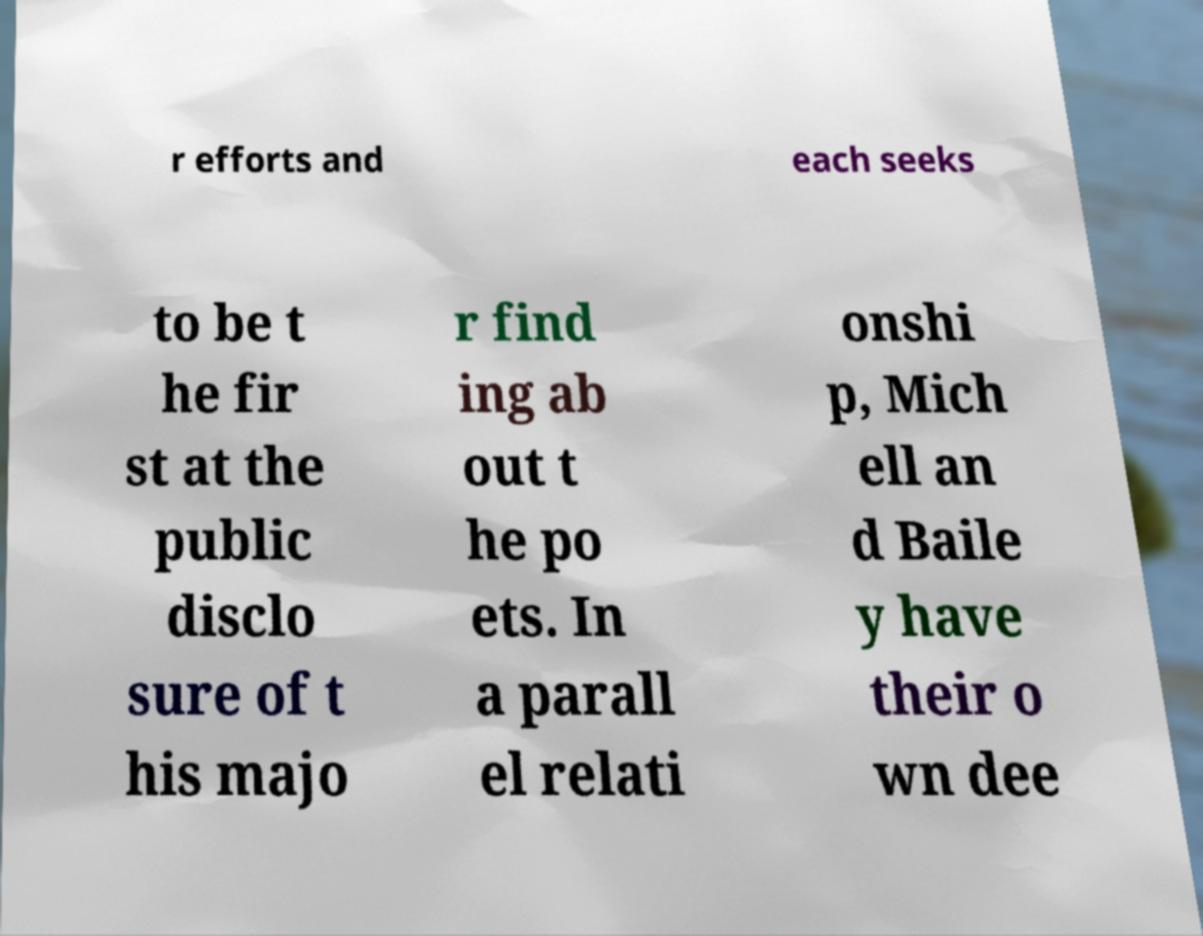Can you accurately transcribe the text from the provided image for me? r efforts and each seeks to be t he fir st at the public disclo sure of t his majo r find ing ab out t he po ets. In a parall el relati onshi p, Mich ell an d Baile y have their o wn dee 